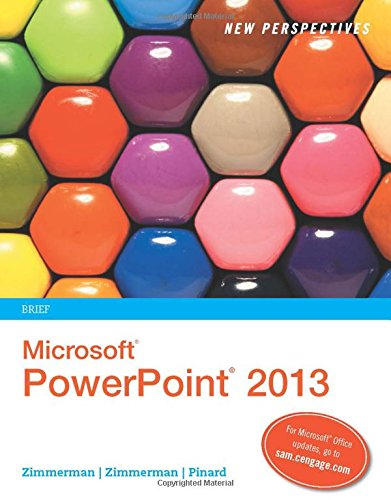What is the visual theme of the cover design for this book? The cover design of the book features a colorful array of rounded shapes that mimic the appearance of a PowerPoint slide template, emphasizing creativity and diversity in presentations. 